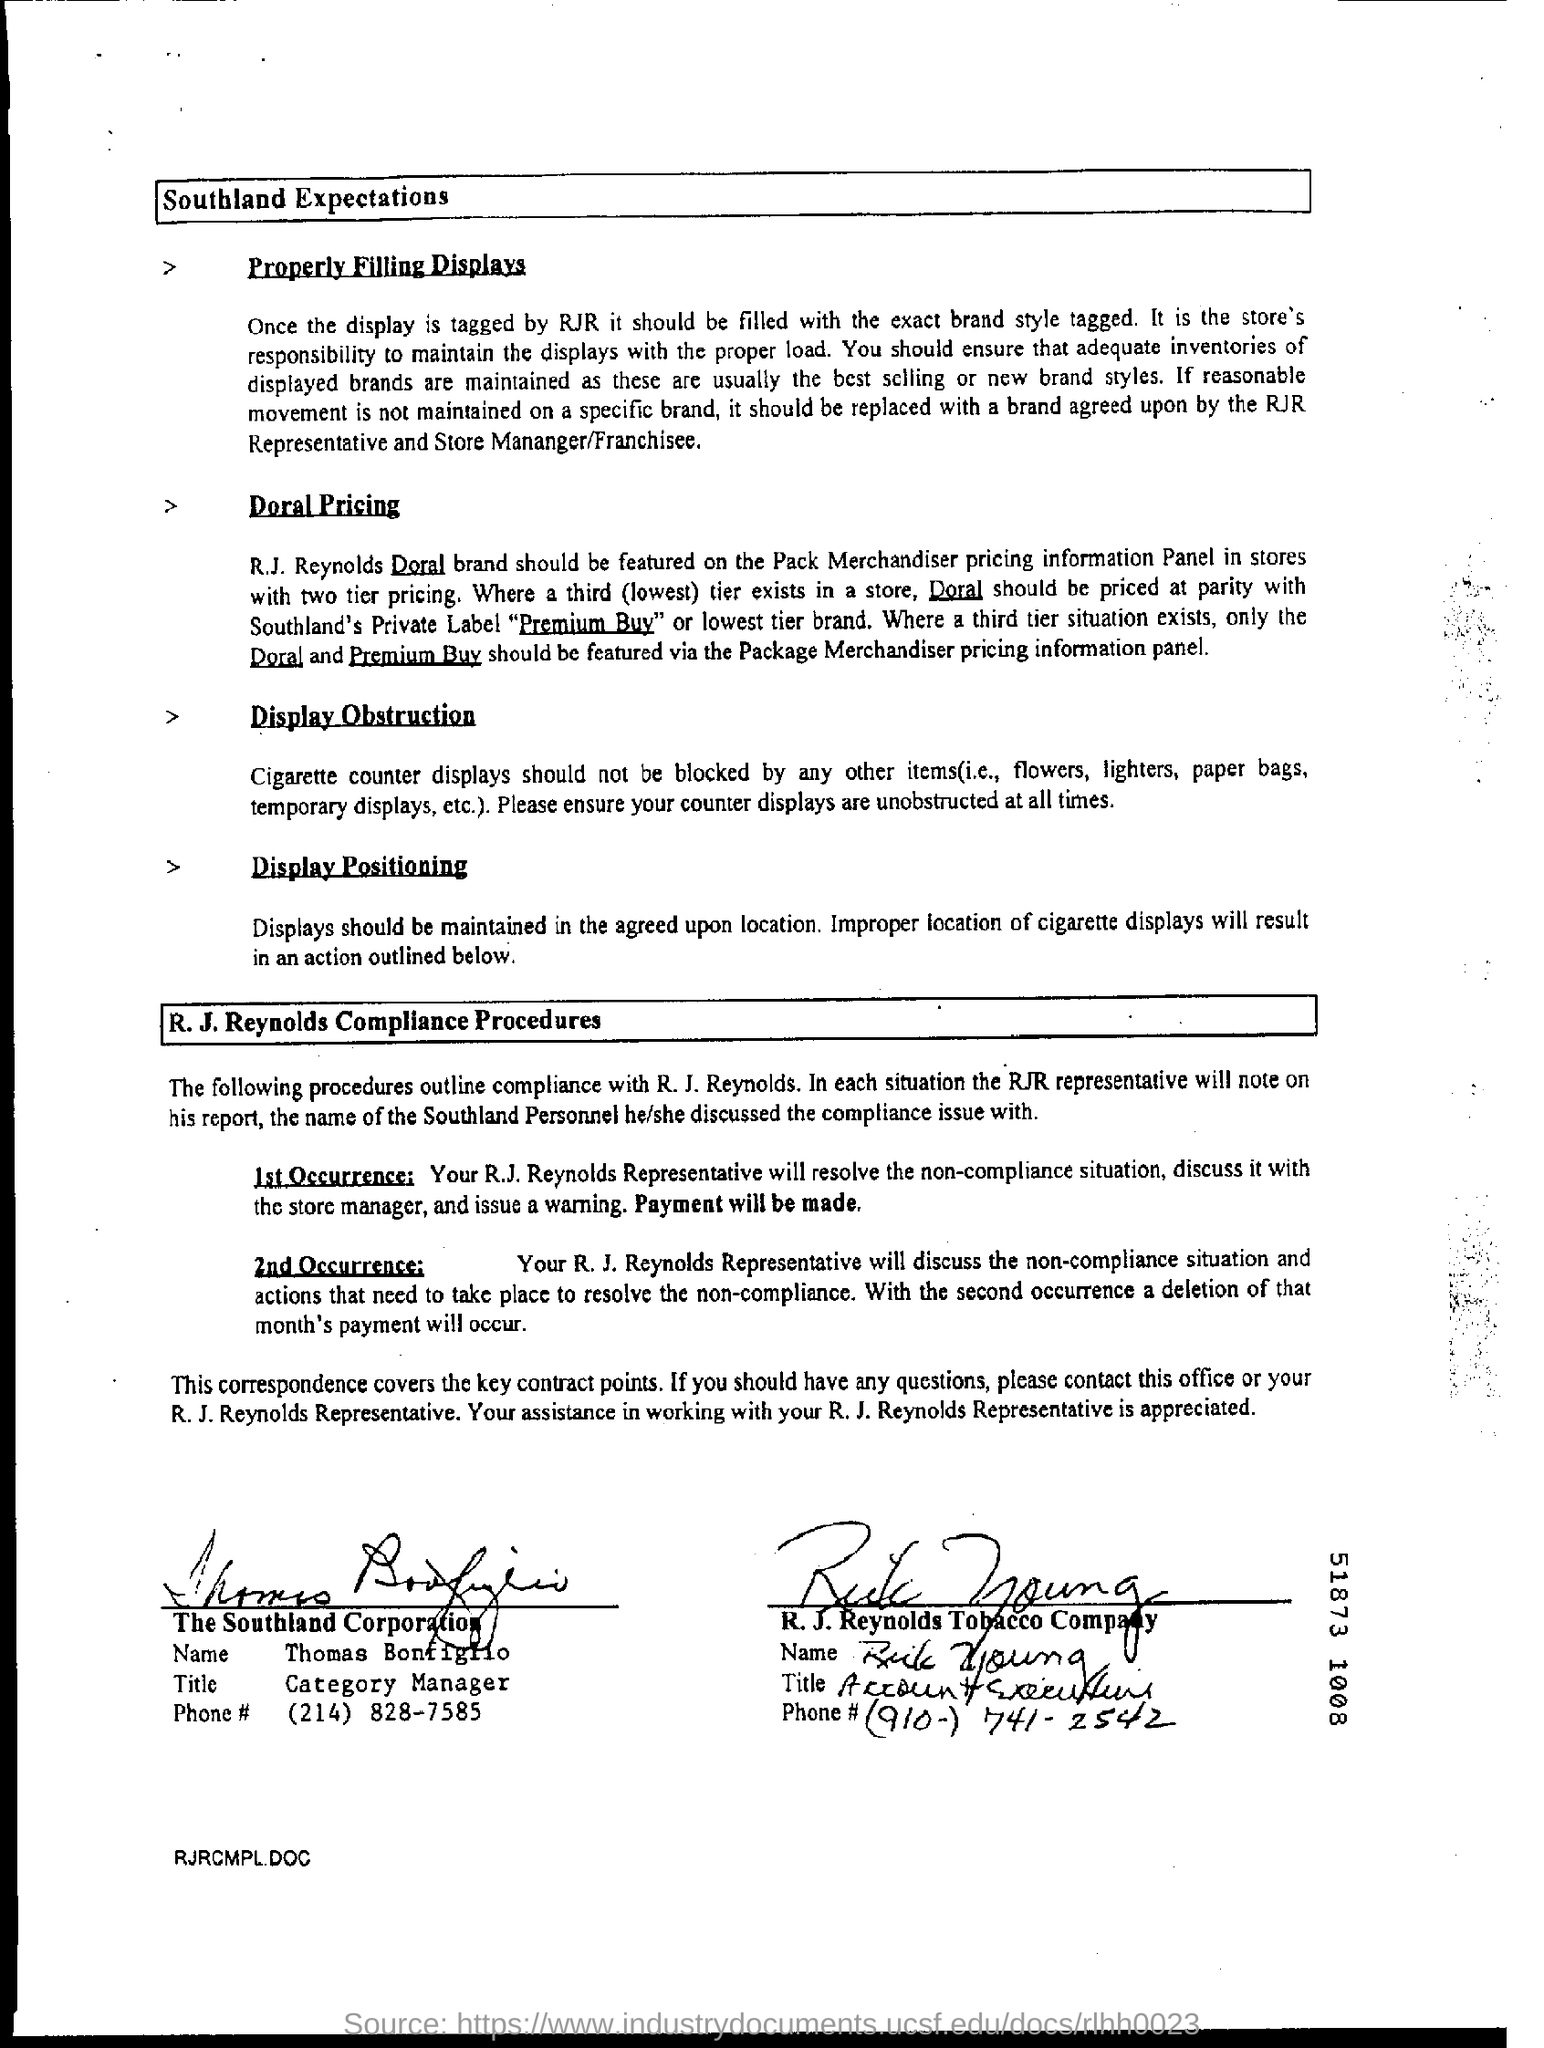Give some essential details in this illustration. The title of Thomas Bonfiglio is Category Manager. 